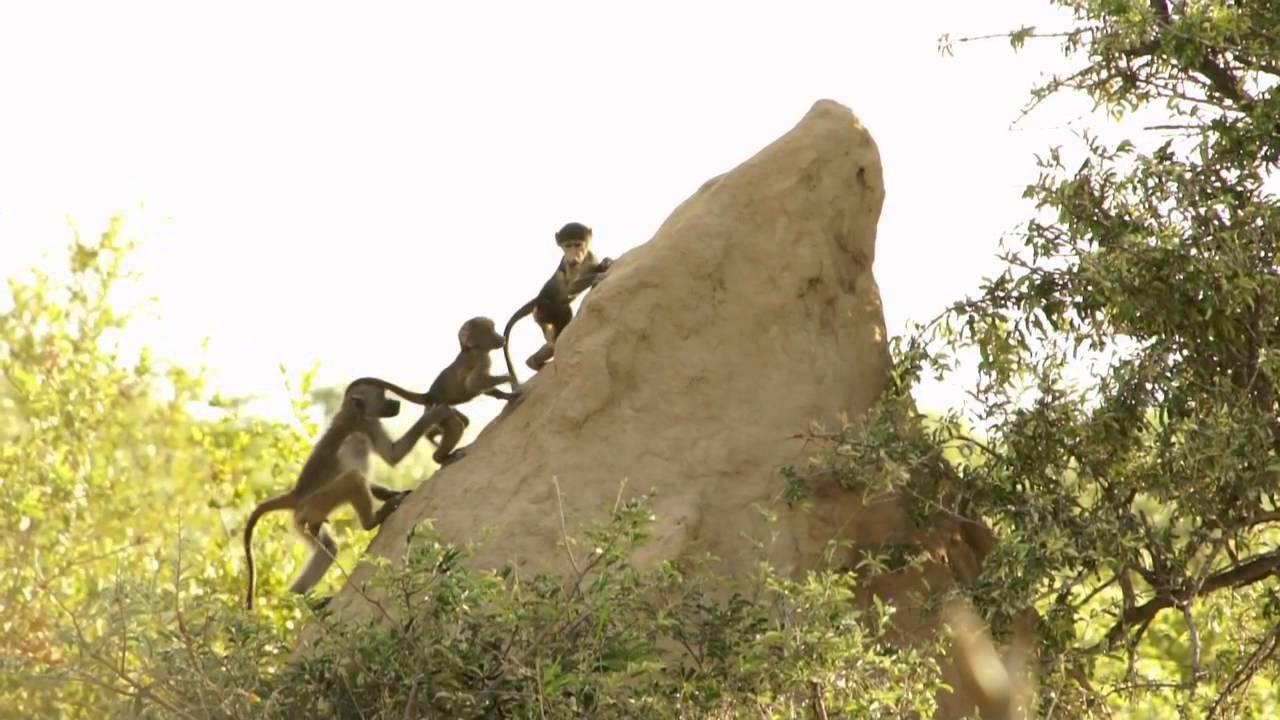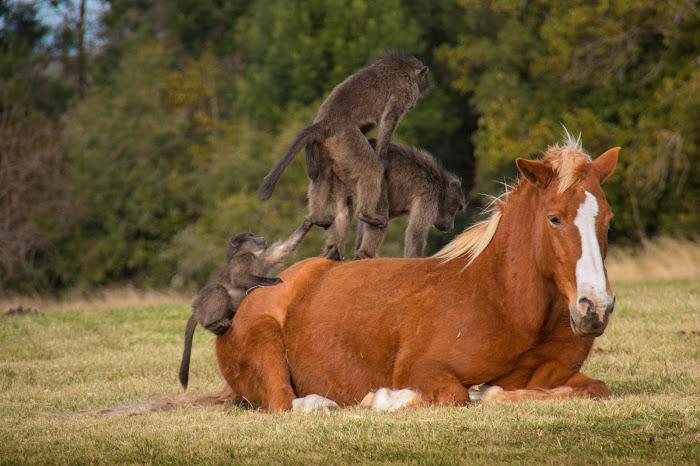The first image is the image on the left, the second image is the image on the right. For the images shown, is this caption "Three monkeys are in a row on a rock in one image." true? Answer yes or no. Yes. The first image is the image on the left, the second image is the image on the right. Assess this claim about the two images: "There are more than three, but no more than five monkeys.". Correct or not? Answer yes or no. No. 